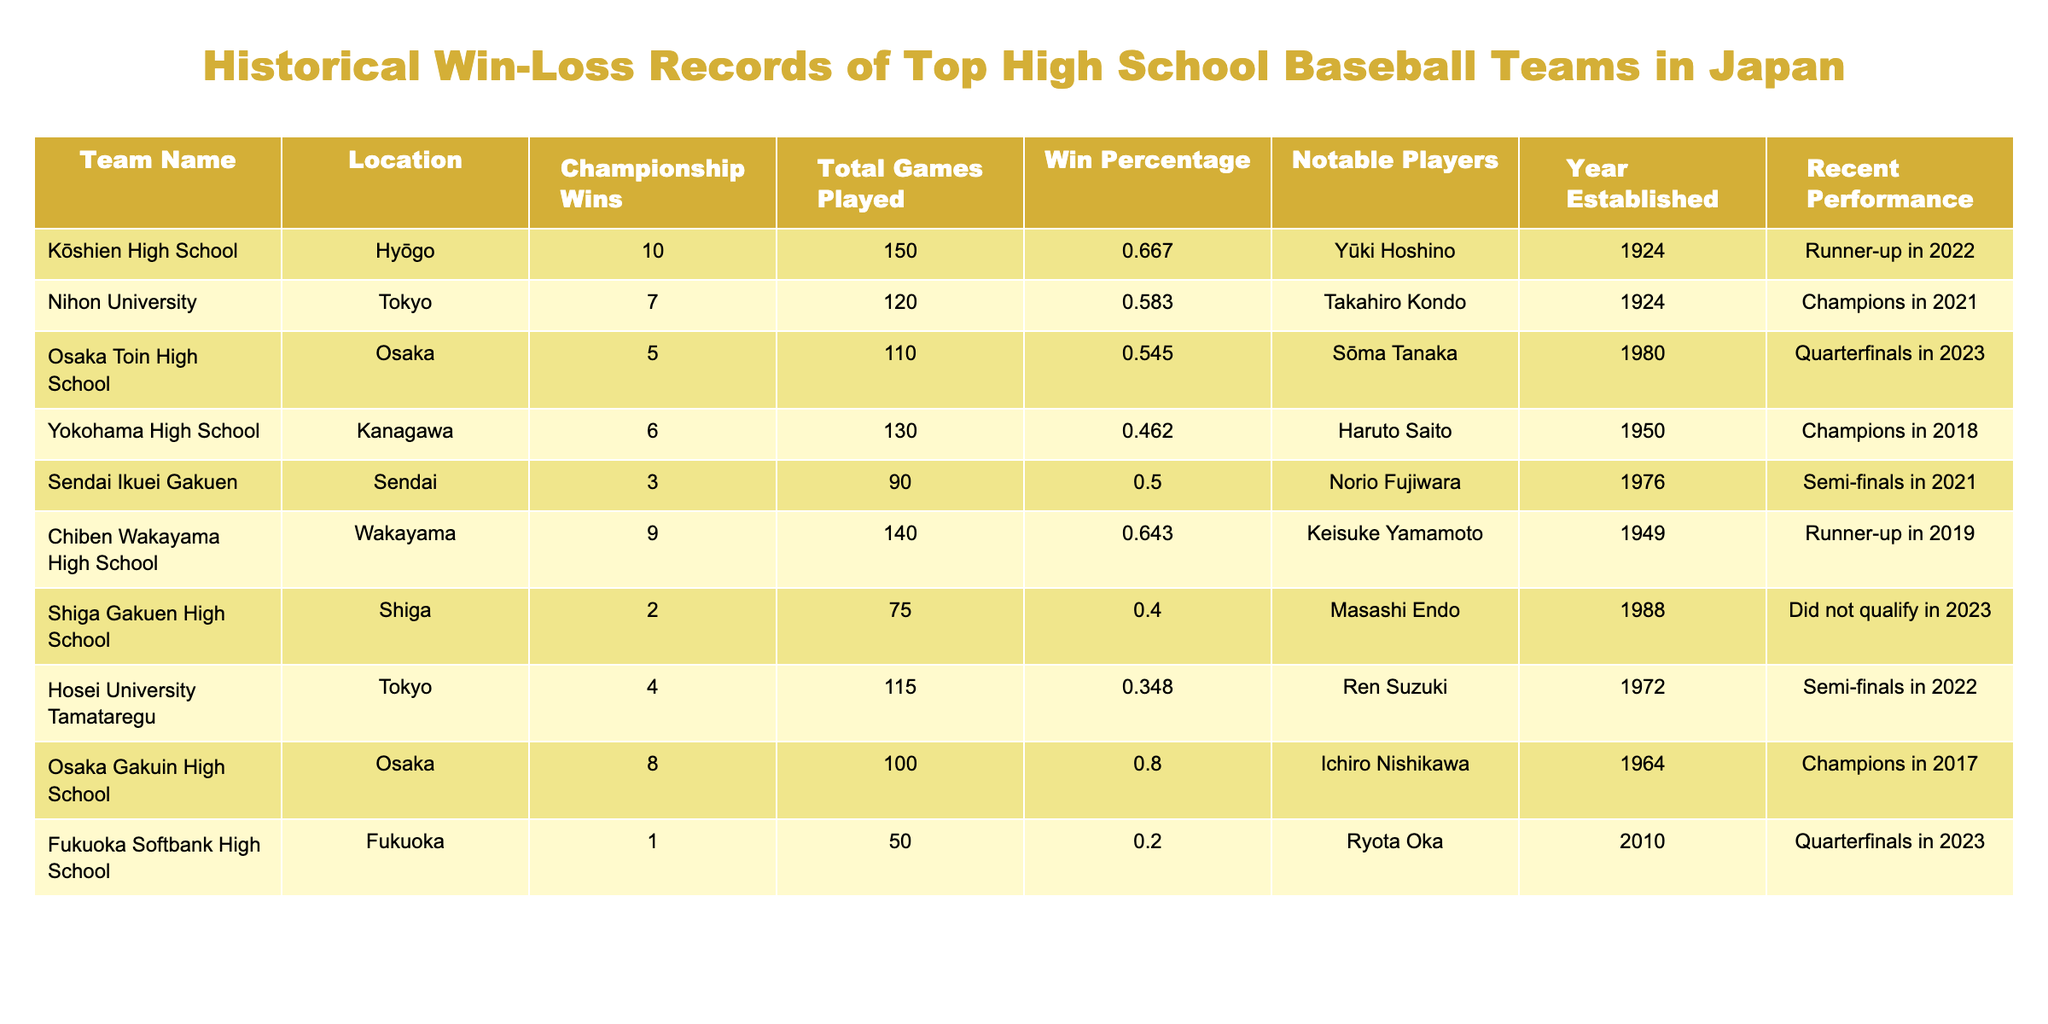What high school baseball team has the most championship wins? By looking at the column for Championship Wins, Kōshien High School has the highest number with 10 wins.
Answer: Kōshien High School Which team has a better win percentage, Osaka Gakuin High School or Nihon University? The win percentage for Osaka Gakuin High School is 0.800, while Nihon University has a win percentage of 0.583. Therefore, Osaka Gakuin High School has a better win percentage.
Answer: Osaka Gakuin High School Do any teams have a win percentage below 0.400? By checking the Win Percentage column, we can see that Hosei University Tamataregu (0.348) and Fukuoka Softbank High School (0.200) both have win percentages below 0.400.
Answer: Yes If we consider only the teams that have won championships, what is the average number of total games played by these teams? The teams with championship wins are Kōshien High School (150), Nihon University (120), Chiben Wakayama High School (140), and Osaka Gakuin High School (100). Their total games are 150 + 120 + 140 + 100 = 610. Dividing by 4 gives an average of 610 / 4 = 152.5.
Answer: 152.5 Which team was established more recently, Sendai Ikuei Gakuen or Fukuoka Softbank High School? By comparing the Year Established column, Sendai Ikuei Gakuen was established in 1976, while Fukuoka Softbank High School was established in 2010. This shows that Fukuoka Softbank High School is more recent.
Answer: Fukuoka Softbank High School How many teams reached the semi-finals in 2021? The teams that reached the semi-finals in 2021 were Sendai Ikuei Gakuen and Hosei University Tamataregu. Therefore, there are 2 teams that reached the semi-finals in that year.
Answer: 2 Is it true that Yokohama High School has won more championships than Osaka Toin High School? Yokohama High School has 6 championship wins, while Osaka Toin High School has 5. Therefore, the statement is true.
Answer: True What is the total number of games played by teams with a win percentage of 0.500 or higher? The teams with a win percentage of 0.500 or higher and their total games played are Kōshien High School (150), Nihon University (120), Chiben Wakayama High School (140), Osaka Gakuin High School (100), and Sendai Ikuei Gakuen (90). Adding these gives 150 + 120 + 140 + 100 + 90 = 600.
Answer: 600 